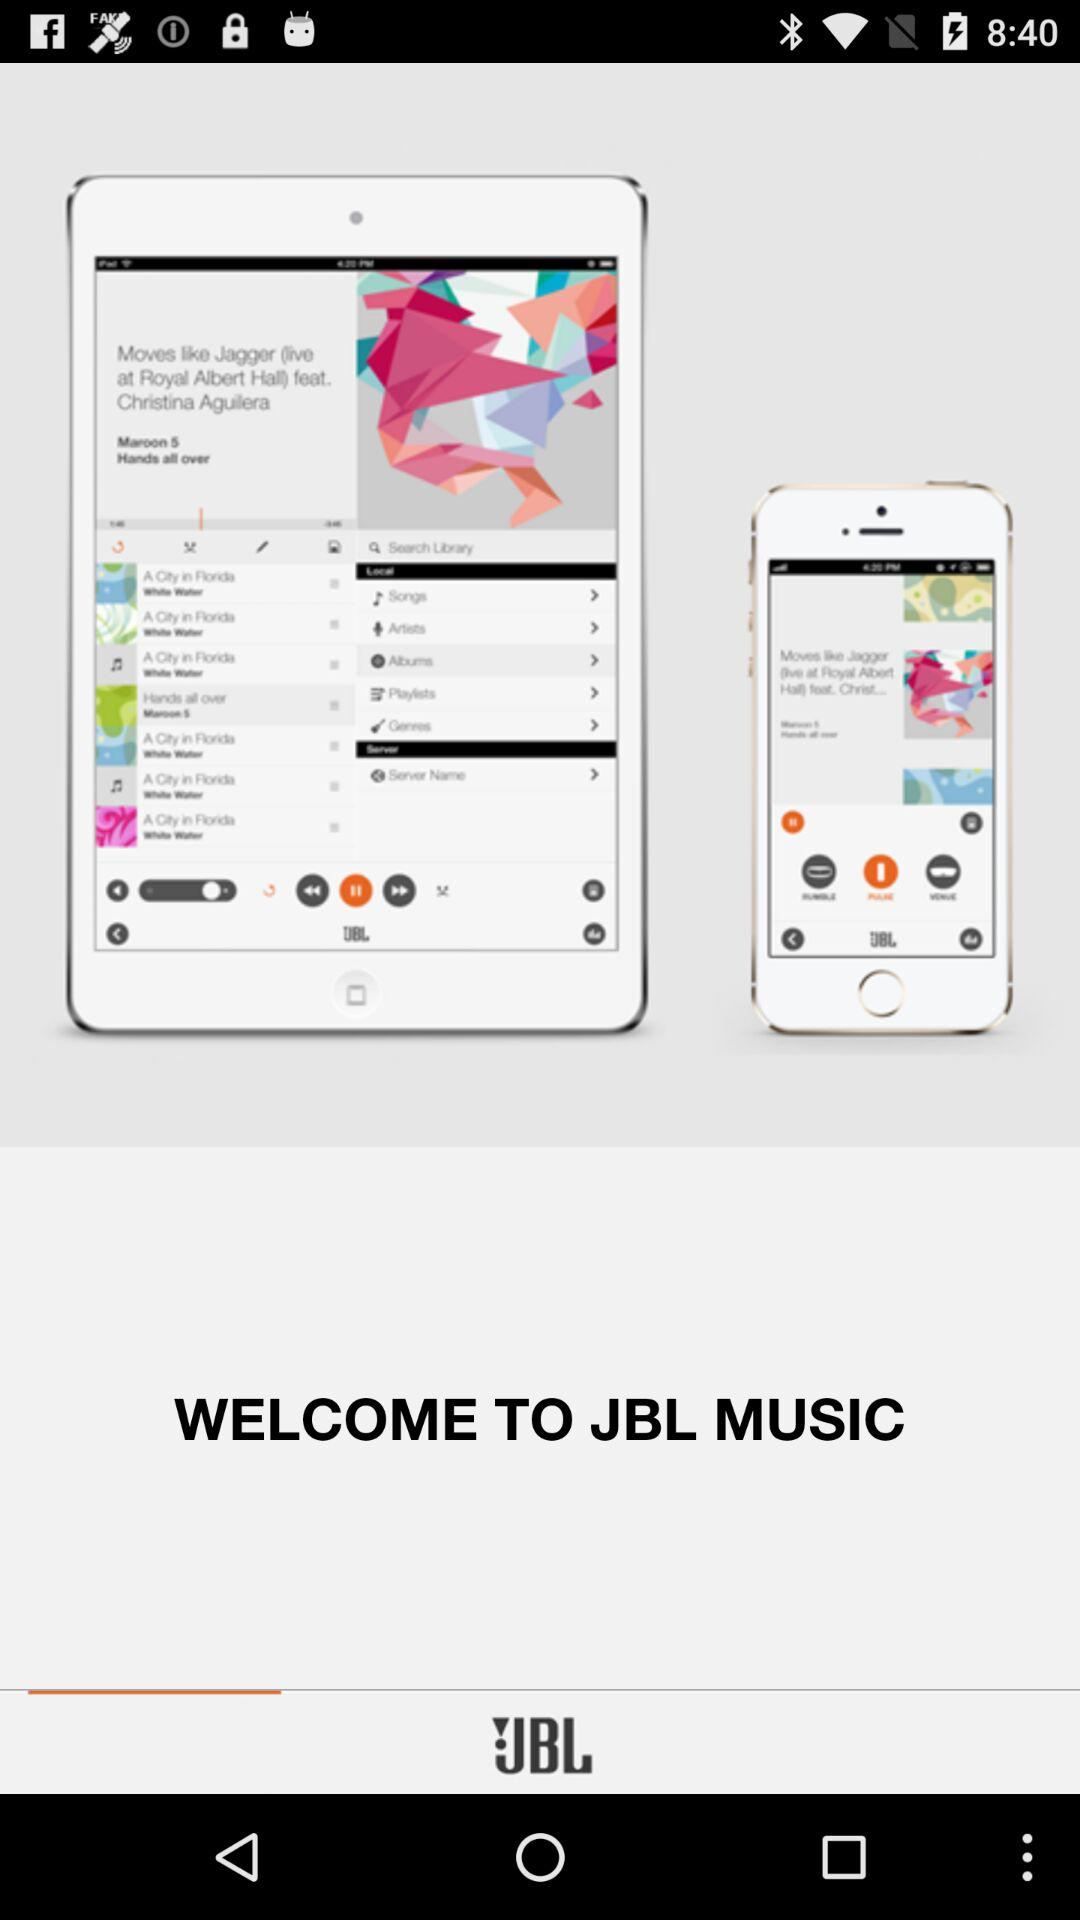What is the application name? The application name is "JBL MUSIC". 